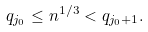Convert formula to latex. <formula><loc_0><loc_0><loc_500><loc_500>q _ { j _ { 0 } } \leq n ^ { 1 / 3 } < q _ { j _ { 0 } + 1 } .</formula> 